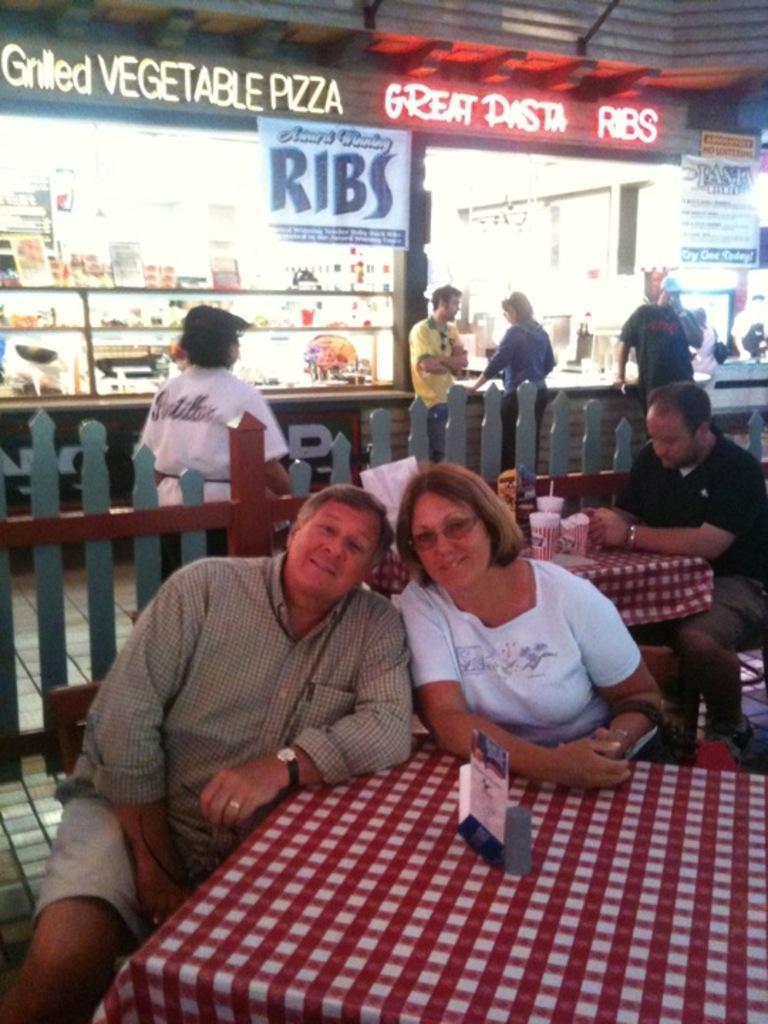Please provide a concise description of this image. In this picture we can see some persons sitting on the chairs besides the table. And there is a cloth on the table. And in the background there is a stall, and some people are standing here. And this is the fence. 